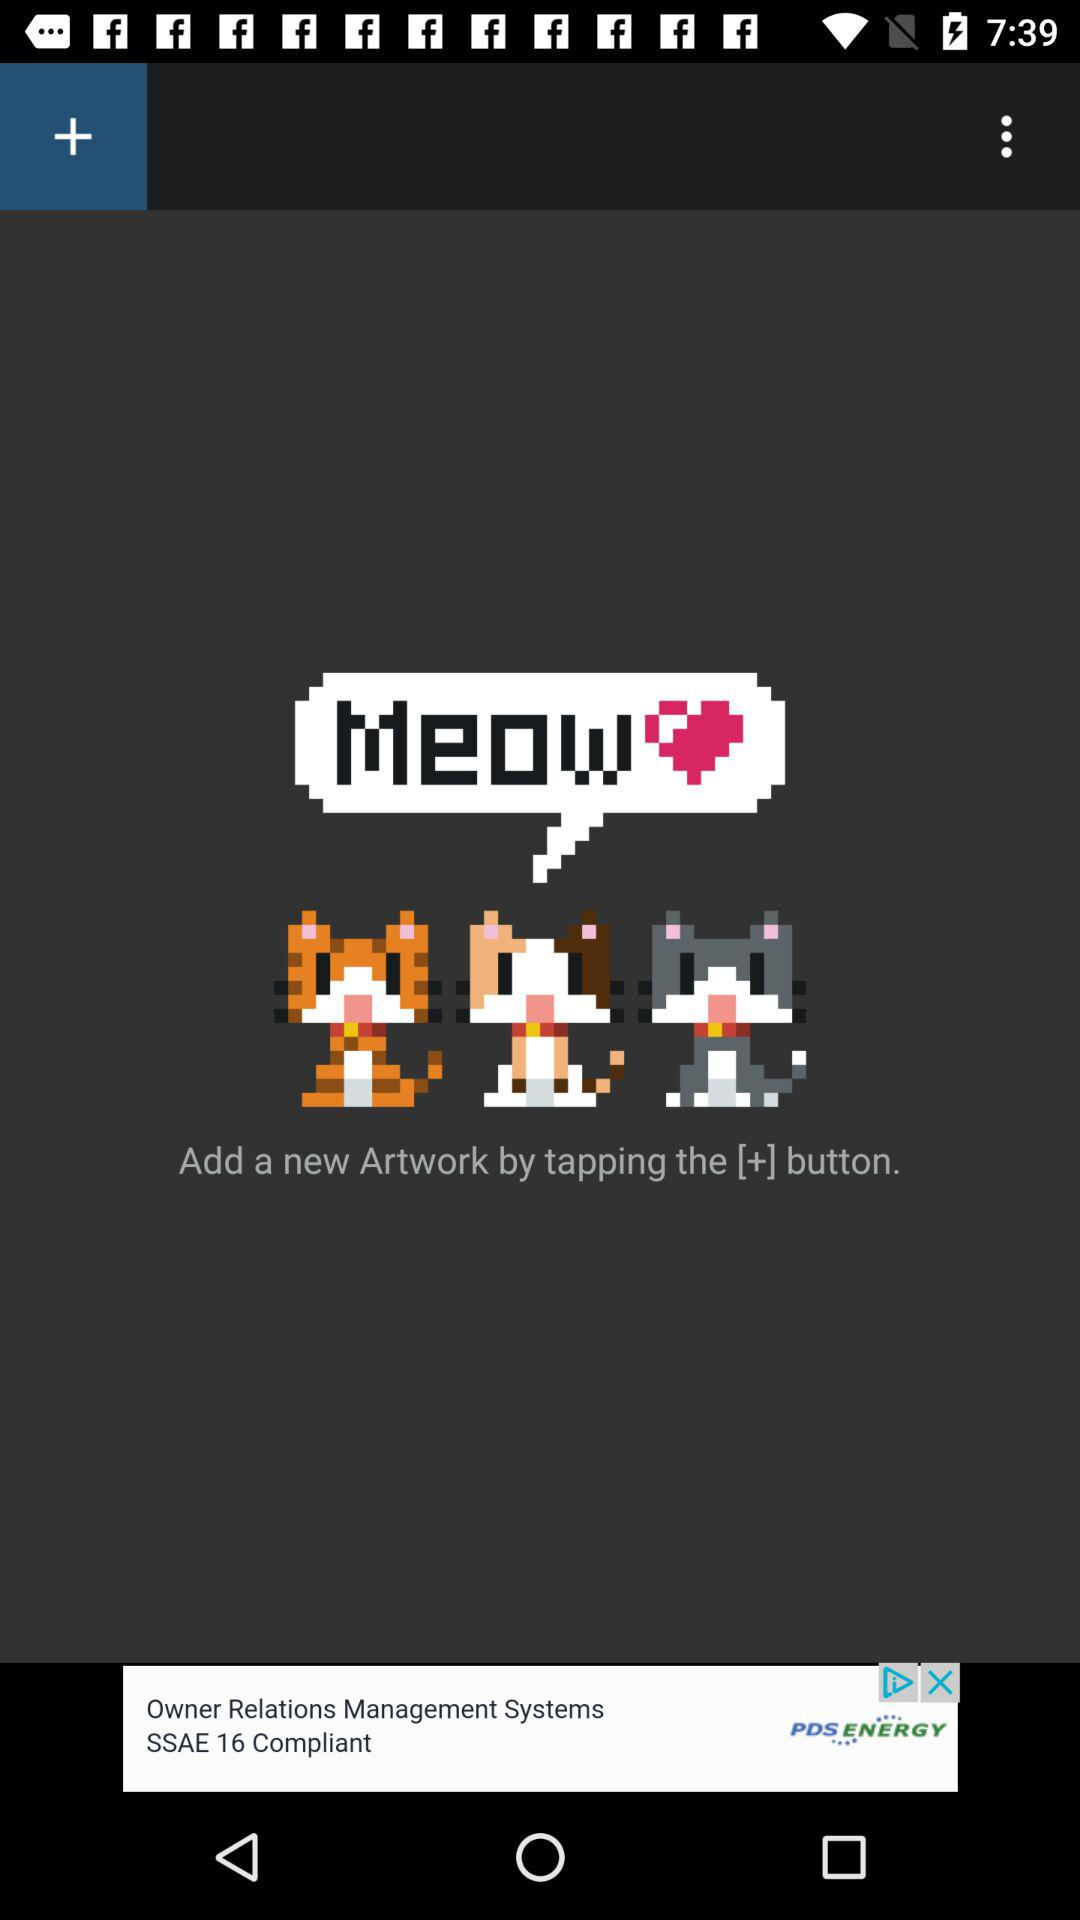How many of the artworks have a cat sitting on a black background?
Answer the question using a single word or phrase. 3 